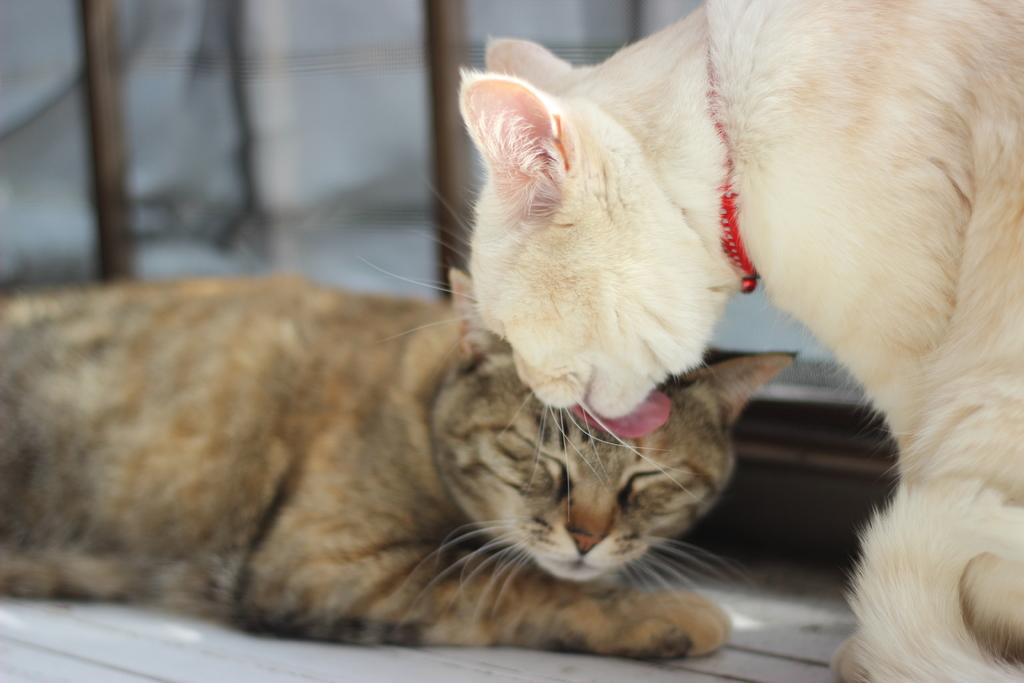How many cats are in the picture? There are two cats in the picture. What colors are the cats? One cat is brown, and the other cat is white. Where are the cats located in the image? The cats are on the right side of the image. What can be seen in the background of the image? There is a wall in the background of the image. What type of secretary is visible in the image? There is no secretary present in the image; it features two cats. How many apples are on the cart in the image? There is no cart or apples present in the image. 